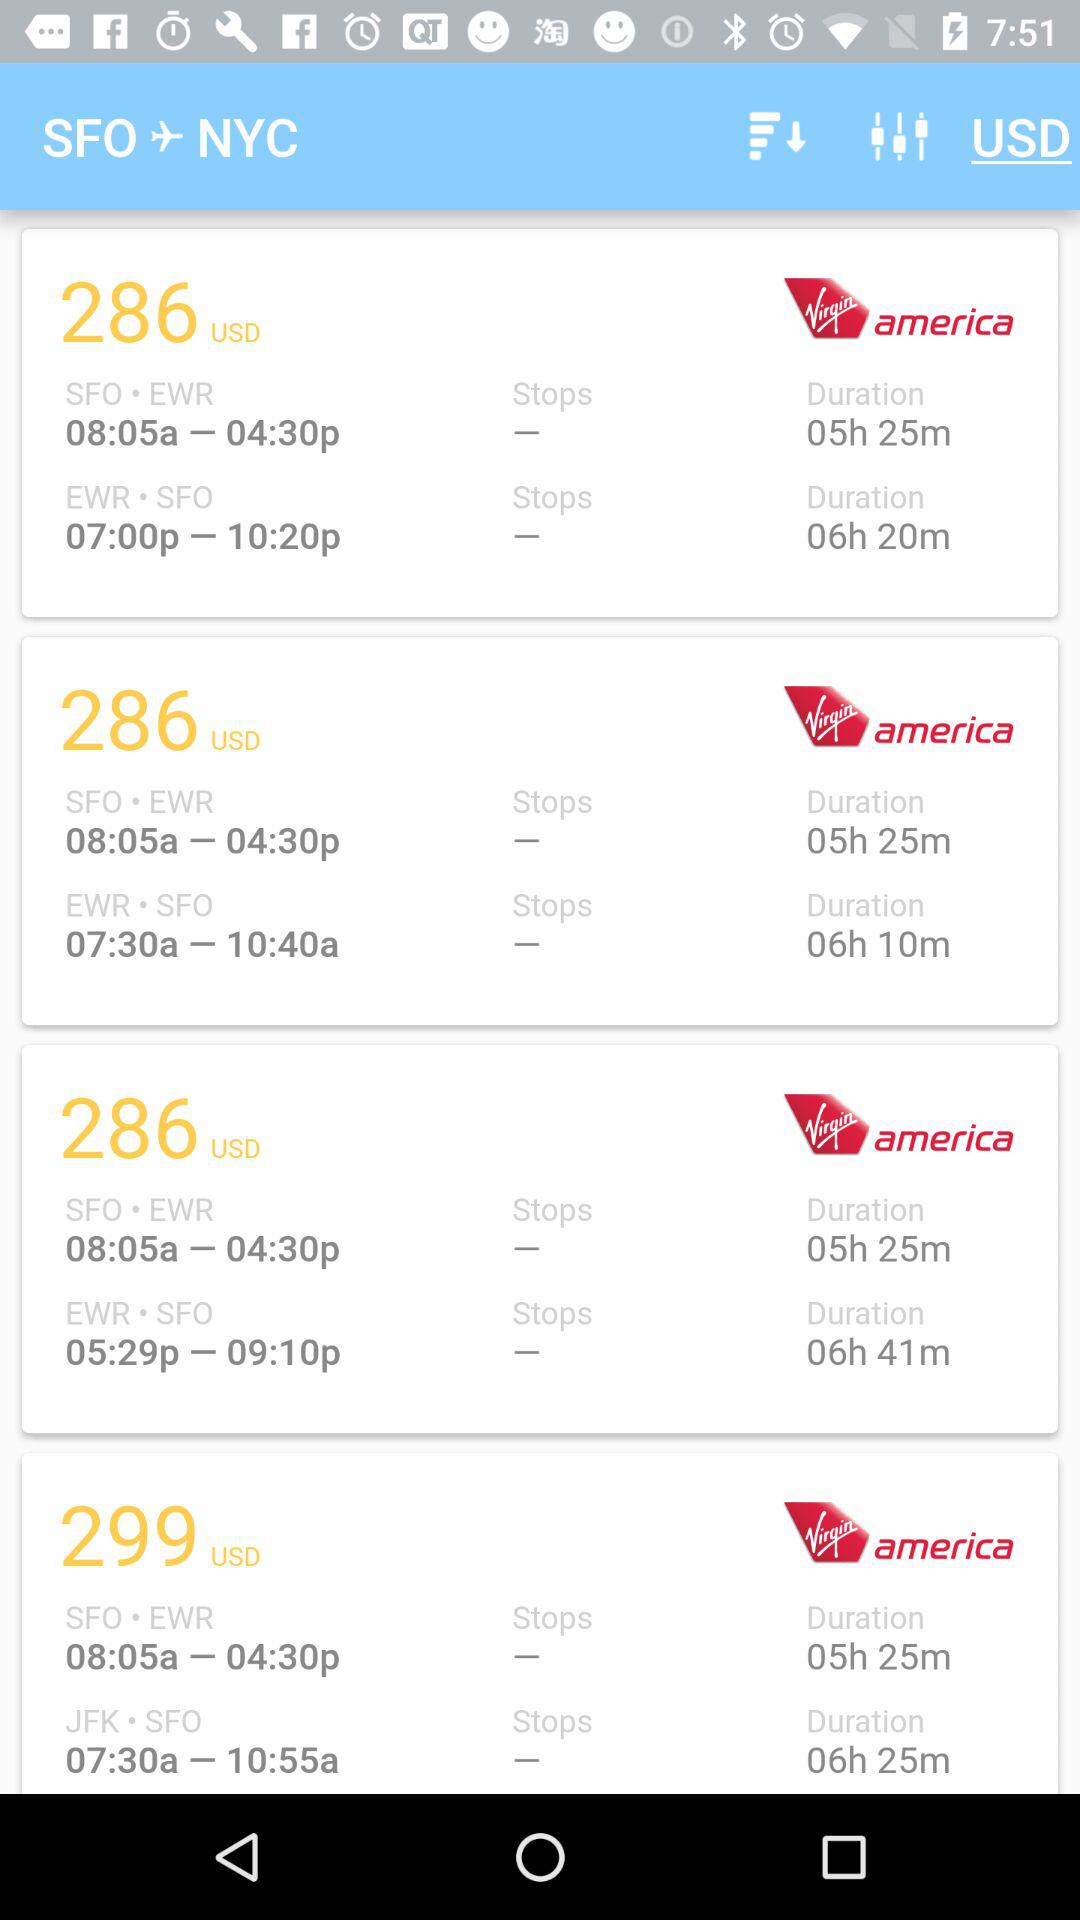Which airline has the most flights from SFO to NYC?
Answer the question using a single word or phrase. Virgin America 